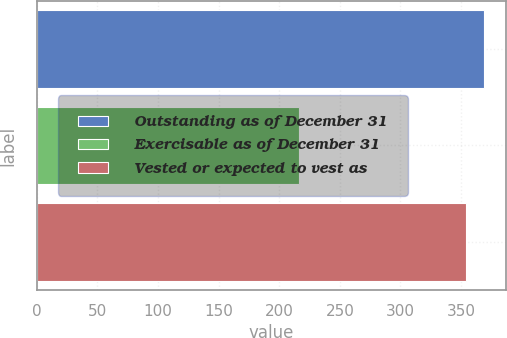Convert chart to OTSL. <chart><loc_0><loc_0><loc_500><loc_500><bar_chart><fcel>Outstanding as of December 31<fcel>Exercisable as of December 31<fcel>Vested or expected to vest as<nl><fcel>368.64<fcel>216.1<fcel>354<nl></chart> 